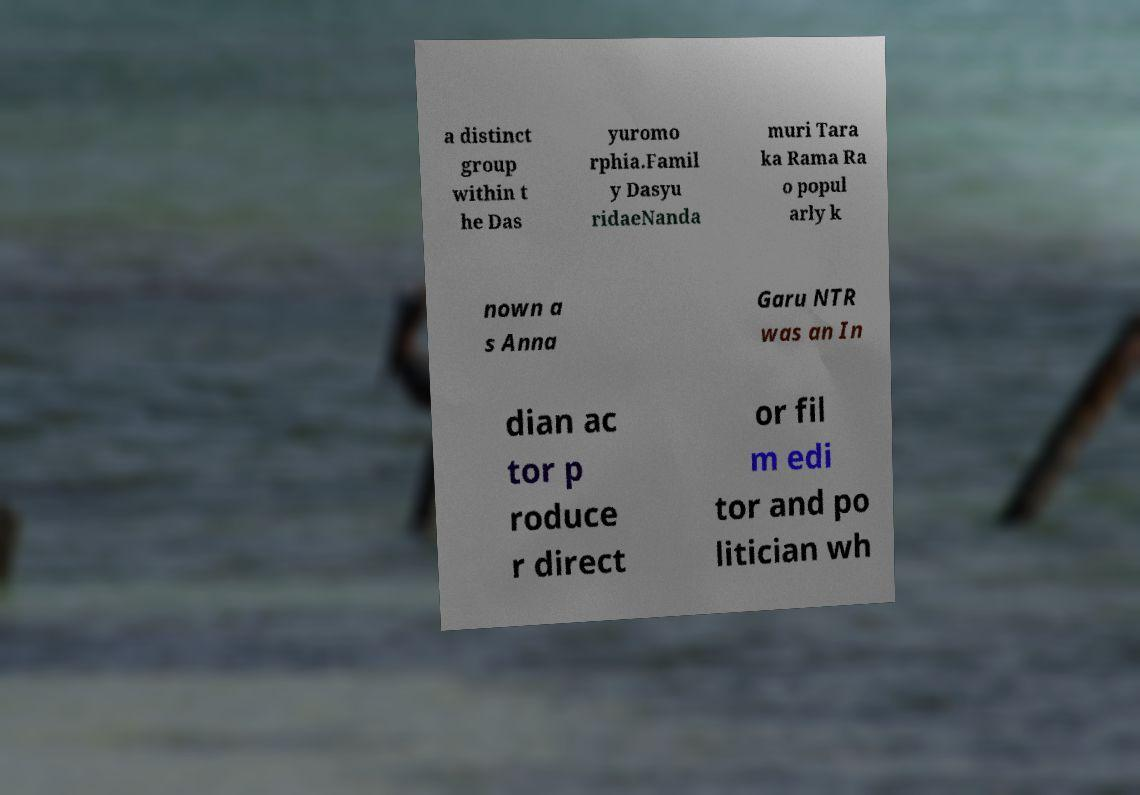Could you extract and type out the text from this image? a distinct group within t he Das yuromo rphia.Famil y Dasyu ridaeNanda muri Tara ka Rama Ra o popul arly k nown a s Anna Garu NTR was an In dian ac tor p roduce r direct or fil m edi tor and po litician wh 